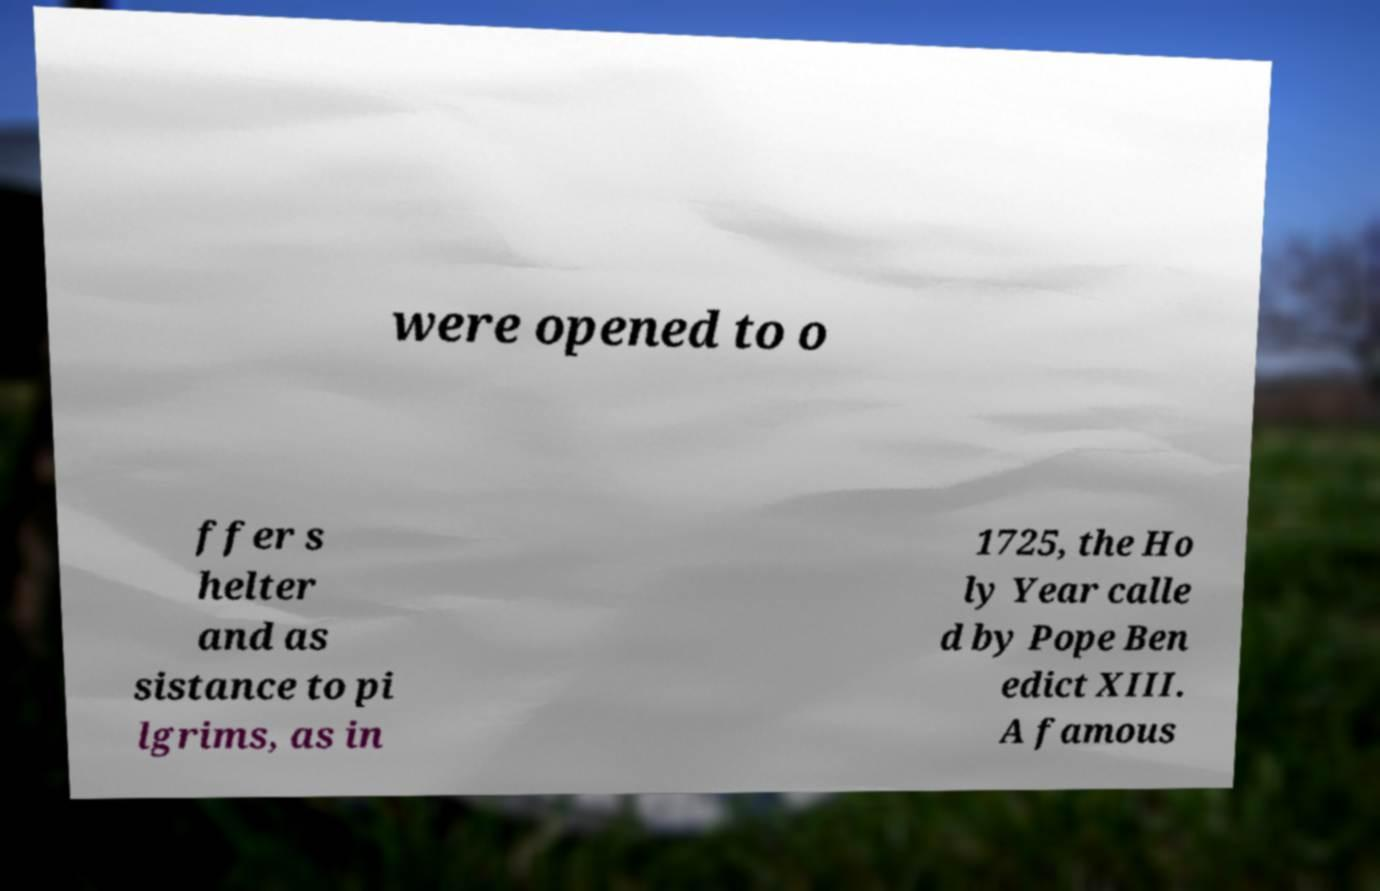For documentation purposes, I need the text within this image transcribed. Could you provide that? were opened to o ffer s helter and as sistance to pi lgrims, as in 1725, the Ho ly Year calle d by Pope Ben edict XIII. A famous 